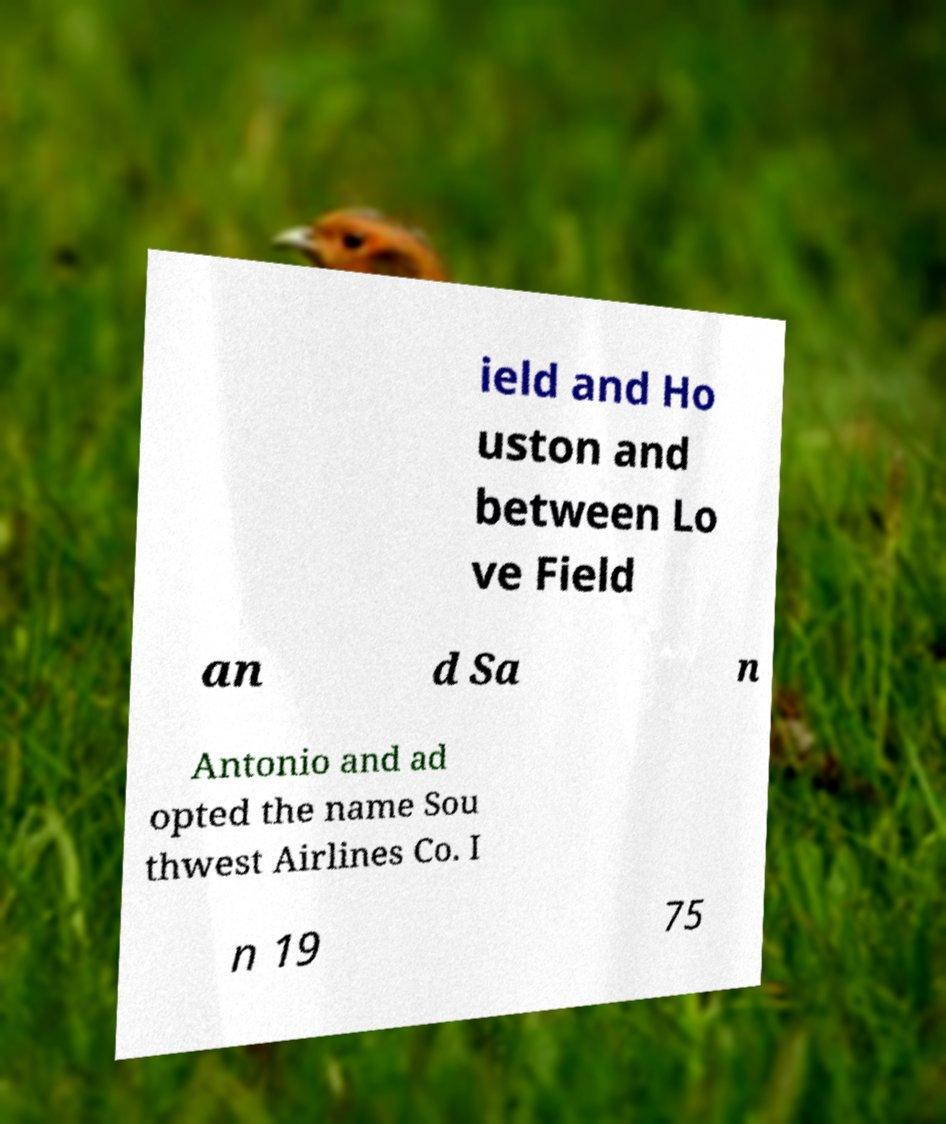For documentation purposes, I need the text within this image transcribed. Could you provide that? ield and Ho uston and between Lo ve Field an d Sa n Antonio and ad opted the name Sou thwest Airlines Co. I n 19 75 